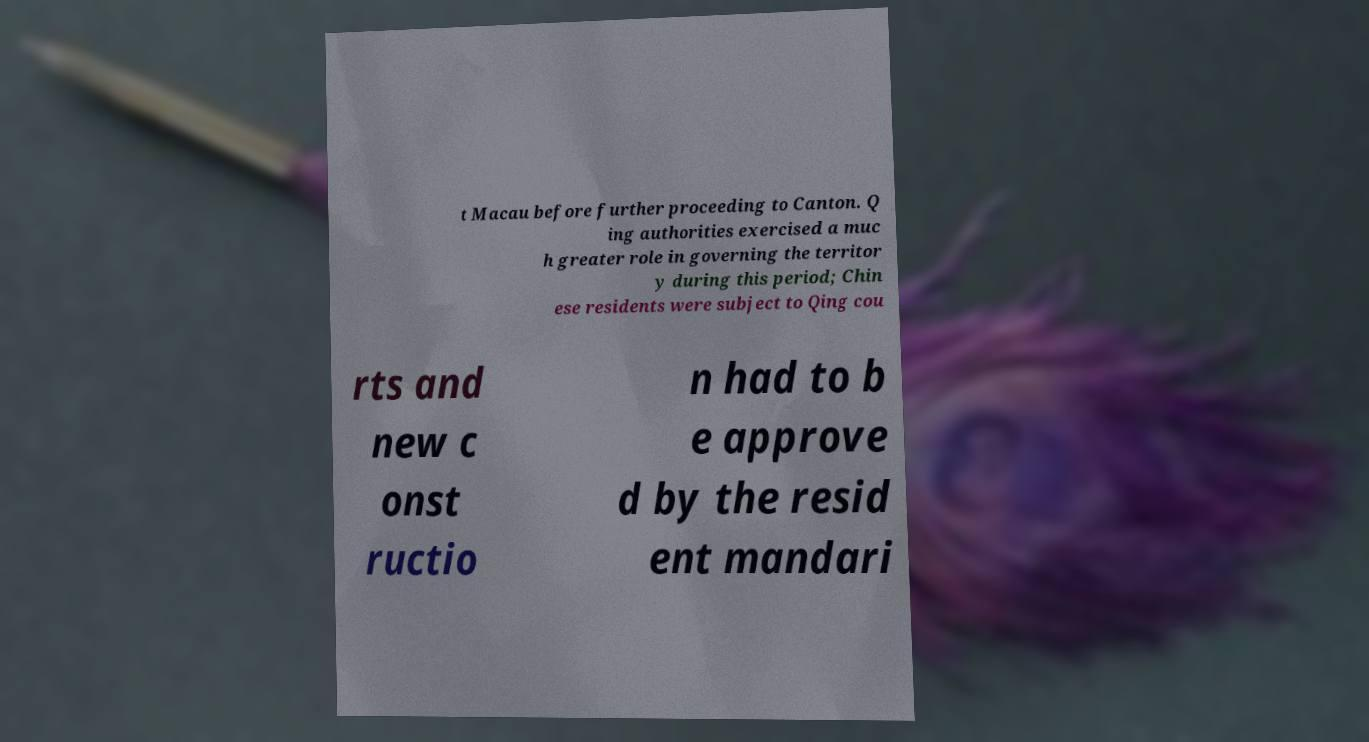I need the written content from this picture converted into text. Can you do that? t Macau before further proceeding to Canton. Q ing authorities exercised a muc h greater role in governing the territor y during this period; Chin ese residents were subject to Qing cou rts and new c onst ructio n had to b e approve d by the resid ent mandari 